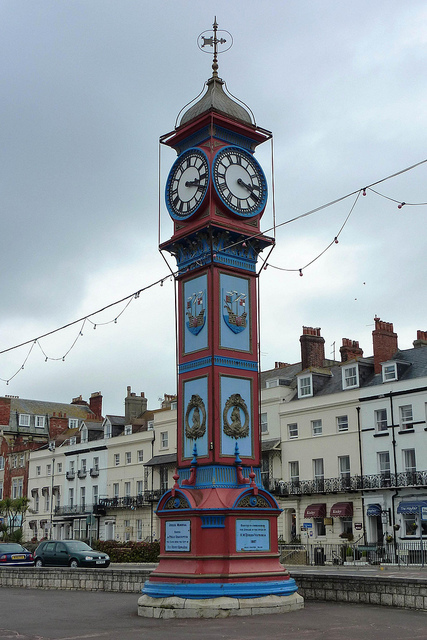Please transcribe the text information in this image. I I I I II II II II III 